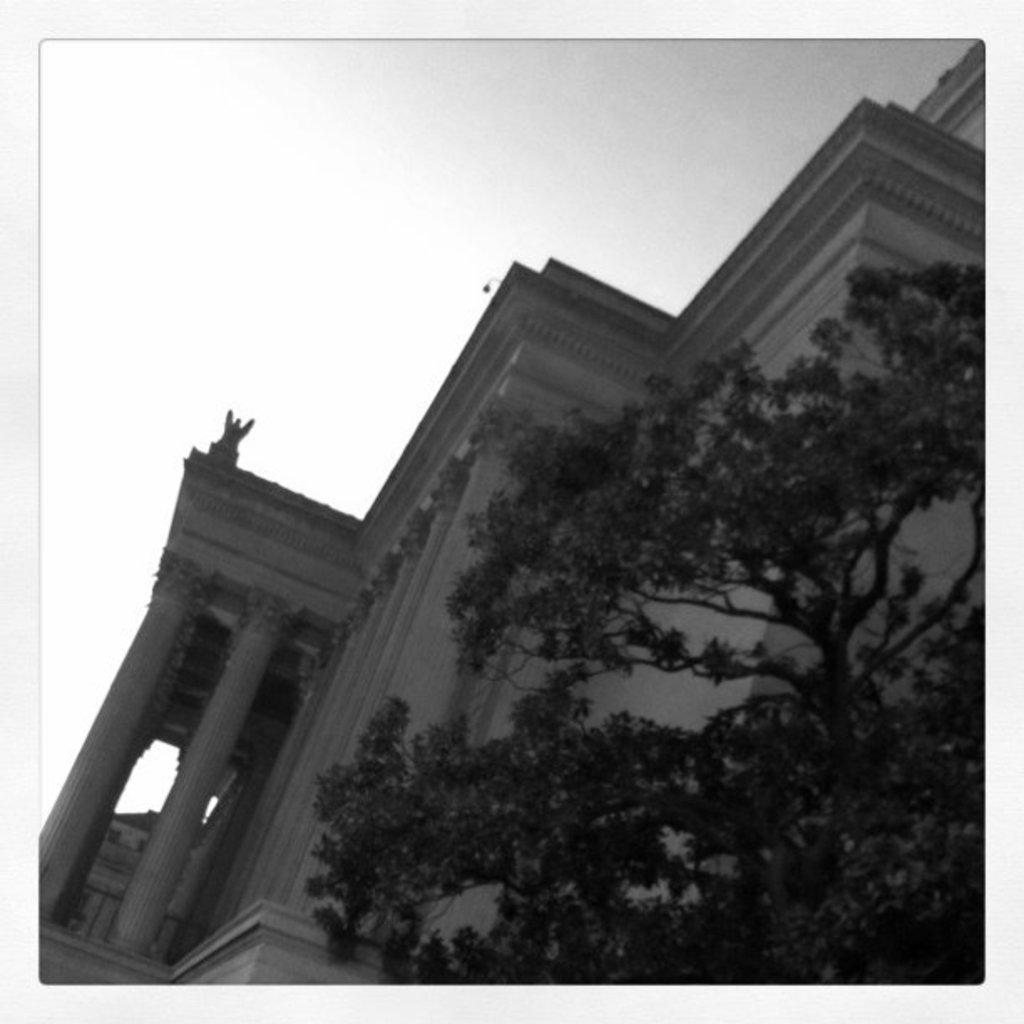What is the main subject of the image? The main subject of the image is a photo of a building. What can be seen in front of the building? There is a tree in front of the building. What is visible in the background of the image? The sky is visible in the background of the image. Can you see any fangs on the tree in the image? There are no fangs present on the tree in the image, as trees do not have fangs. 